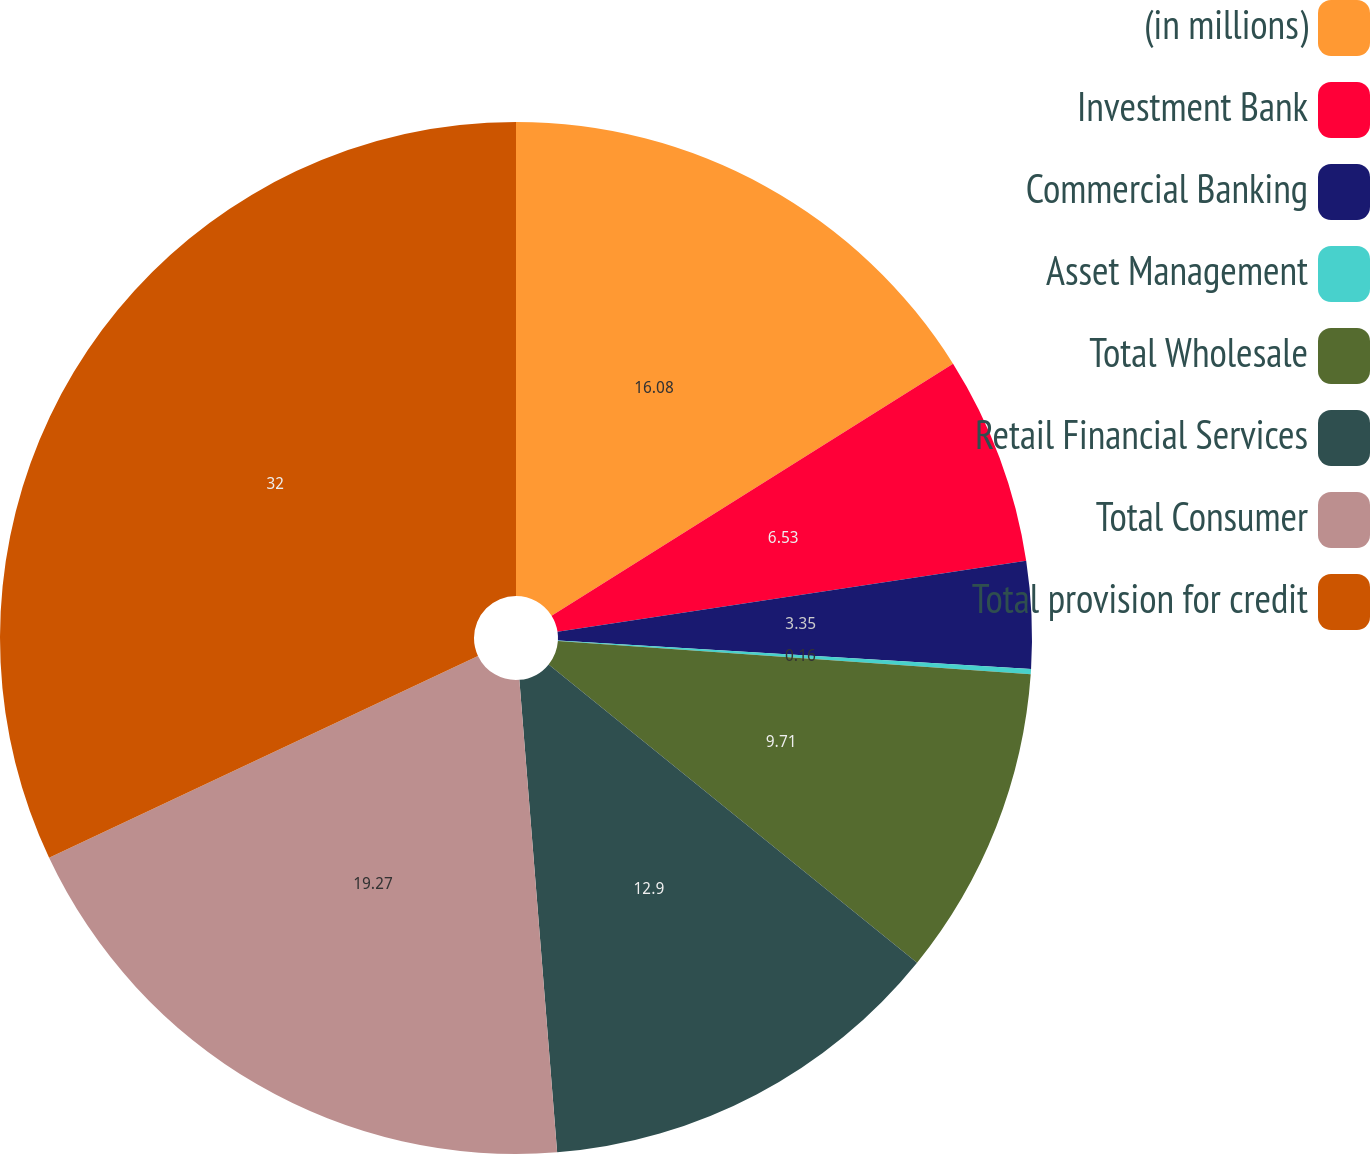Convert chart to OTSL. <chart><loc_0><loc_0><loc_500><loc_500><pie_chart><fcel>(in millions)<fcel>Investment Bank<fcel>Commercial Banking<fcel>Asset Management<fcel>Total Wholesale<fcel>Retail Financial Services<fcel>Total Consumer<fcel>Total provision for credit<nl><fcel>16.08%<fcel>6.53%<fcel>3.35%<fcel>0.16%<fcel>9.71%<fcel>12.9%<fcel>19.27%<fcel>32.0%<nl></chart> 